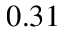<formula> <loc_0><loc_0><loc_500><loc_500>0 . 3 1</formula> 